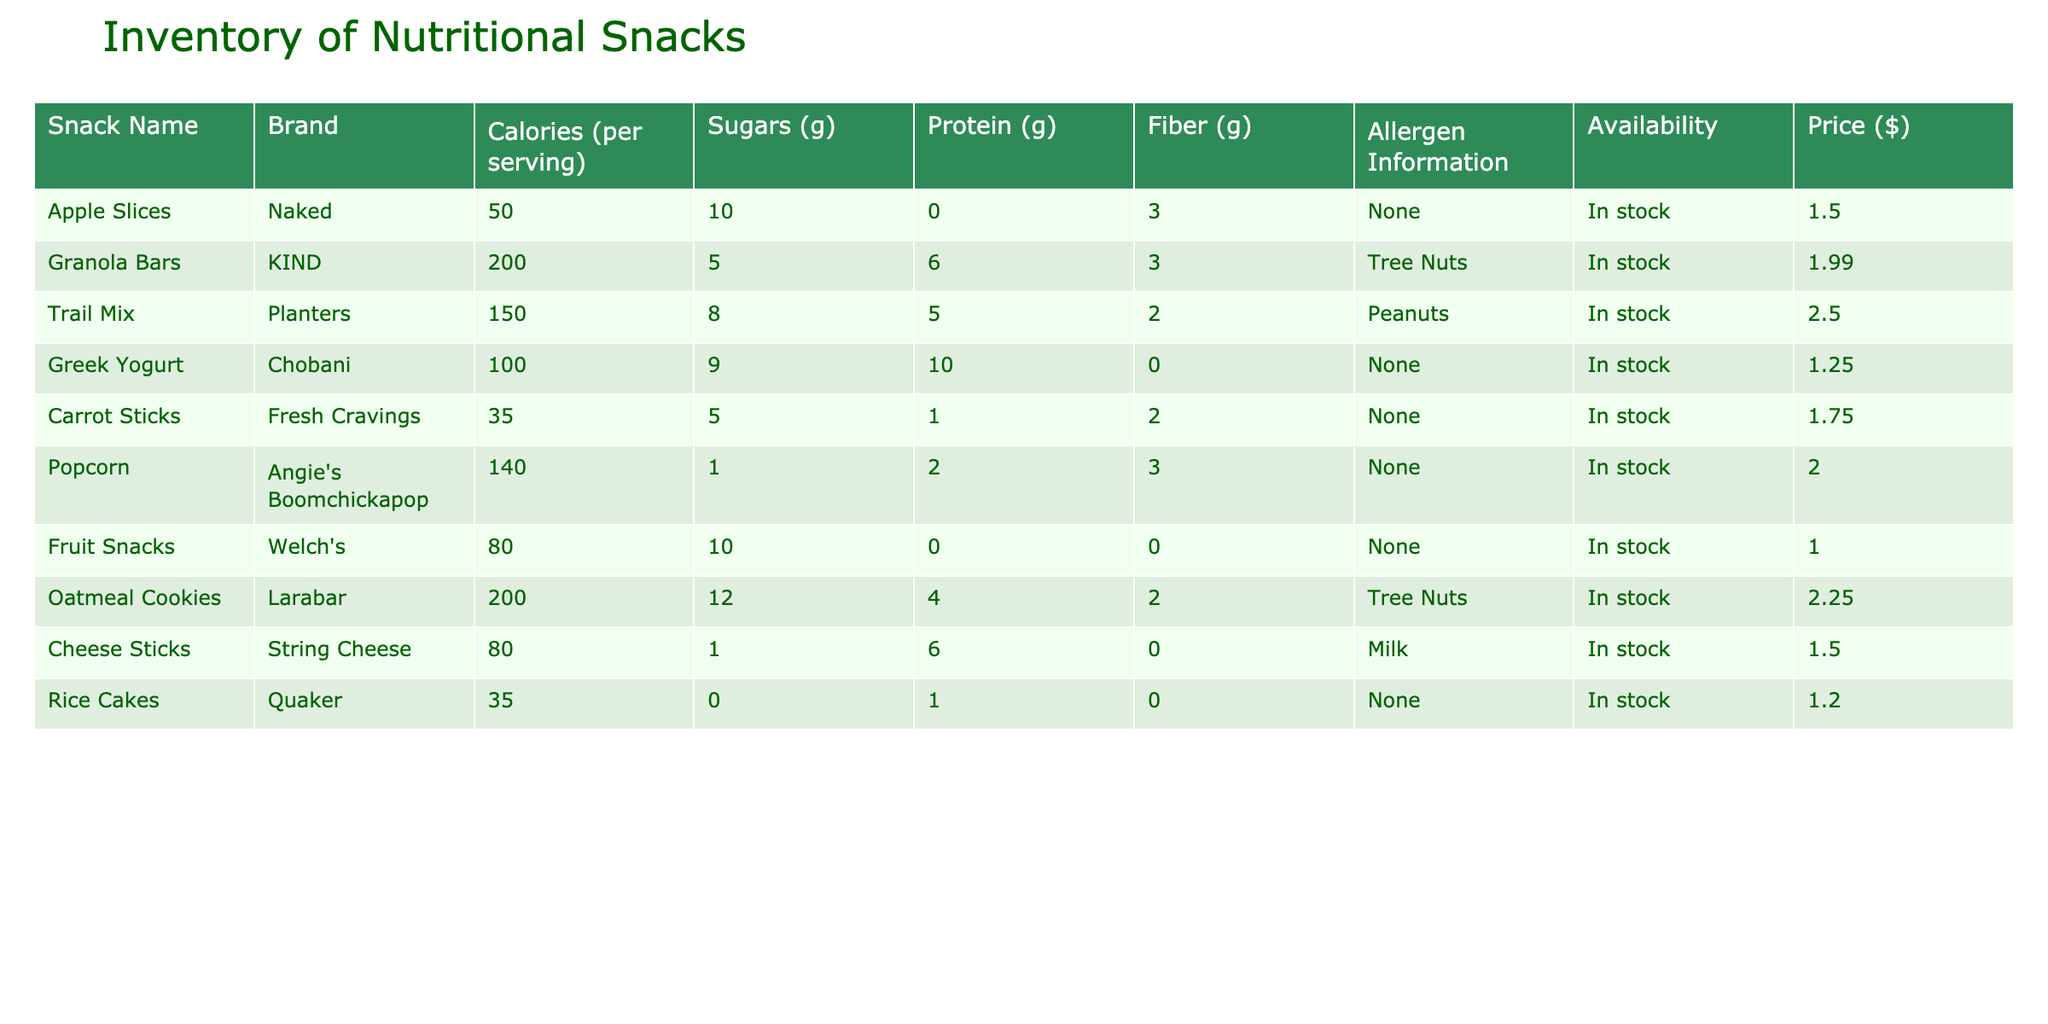What is the most expensive snack in the inventory? The prices of the snacks are listed in the table. Scanning through the Price column, the highest value is for the Oatmeal Cookies at 2.25.
Answer: Oatmeal Cookies Which snack has the highest protein content? The Protein column shows the values for each snack. Comparing the values, Greek Yogurt has the highest protein content at 10 grams per serving.
Answer: Greek Yogurt What is the total calorie count for Apple Slices and Carrot Sticks combined? The calorie content for Apple Slices is 50 and for Carrot Sticks is 35. Therefore, the total is calculated as 50 + 35 = 85.
Answer: 85 Are there any snacks that contain tree nuts as an allergen? Looking at the Allergen Information column, Granola Bars and Oatmeal Cookies list tree nuts as an allergen. Therefore, yes, there are snacks with tree nuts.
Answer: Yes What snack has the lowest amount of sugars? By examining the Sugars column, Carrot Sticks have the lowest amount with just 5 grams of sugar.
Answer: Carrot Sticks Is there any snack that has both no sugars and no allergens? According to the table, Rice Cakes have 0 grams of sugars and no allergens. Thus, there exists at least one snack that meets these criteria.
Answer: Yes What is the average calorie count of all snacks listed? The total calorie count of all snacks is 50 + 200 + 150 + 100 + 35 + 140 + 80 + 200 + 80 + 35 = 1,070. There are 10 snacks, so the average is 1,070 / 10 = 107.
Answer: 107 Which snack is both low in calories and sugars? Looking at both the Calories and Sugars columns, Carrot Sticks have the lowest calories at 35 and sugars at 5 grams. Thus, they qualify as low in both.
Answer: Carrot Sticks 